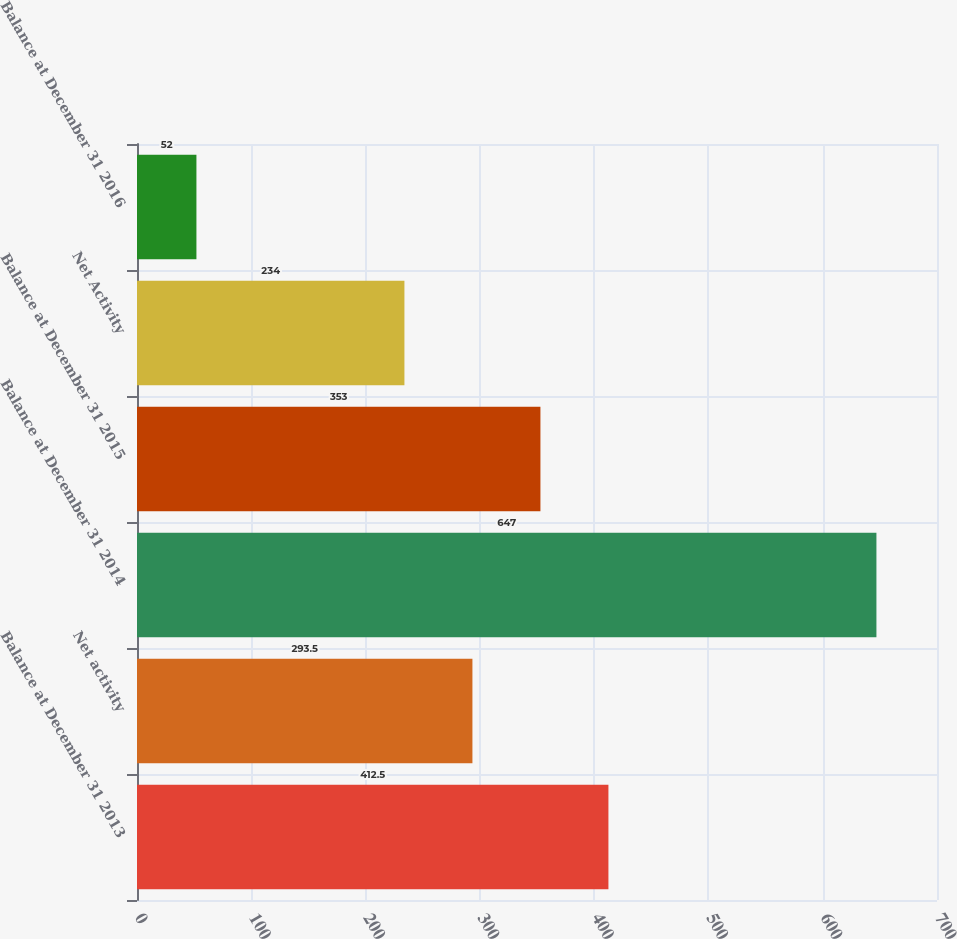Convert chart. <chart><loc_0><loc_0><loc_500><loc_500><bar_chart><fcel>Balance at December 31 2013<fcel>Net activity<fcel>Balance at December 31 2014<fcel>Balance at December 31 2015<fcel>Net Activity<fcel>Balance at December 31 2016<nl><fcel>412.5<fcel>293.5<fcel>647<fcel>353<fcel>234<fcel>52<nl></chart> 